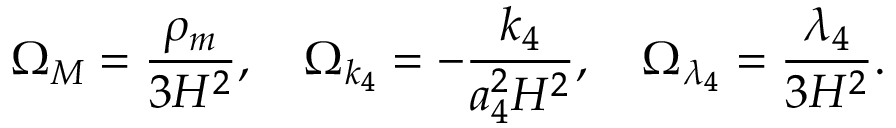Convert formula to latex. <formula><loc_0><loc_0><loc_500><loc_500>\Omega _ { M } = \frac { \rho _ { m } } { 3 H ^ { 2 } } , \quad \Omega _ { k _ { 4 } } = - \frac { k _ { 4 } } { a _ { 4 } ^ { 2 } H ^ { 2 } } , \quad \Omega _ { \lambda _ { 4 } } = \frac { \lambda _ { 4 } } { 3 H ^ { 2 } } .</formula> 